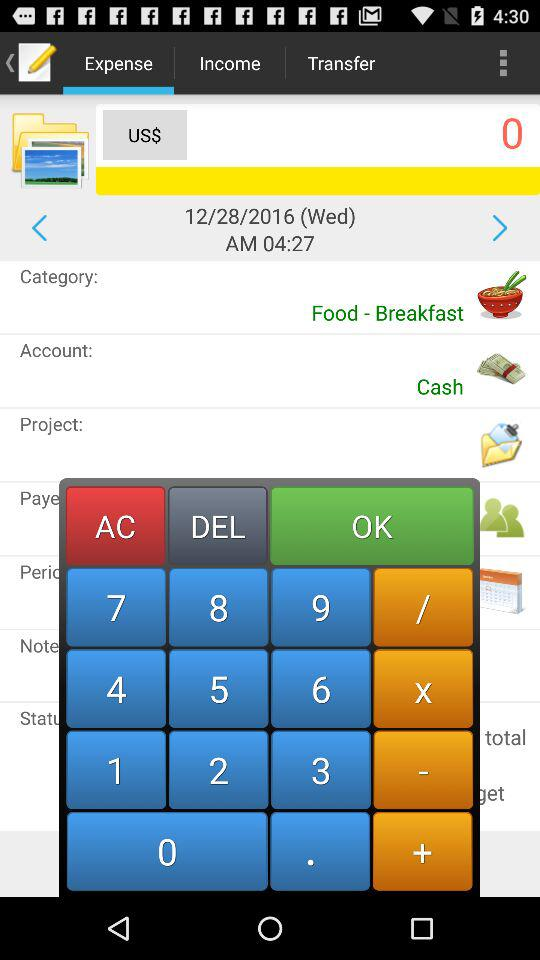What is the food category? The food category is breakfast. 